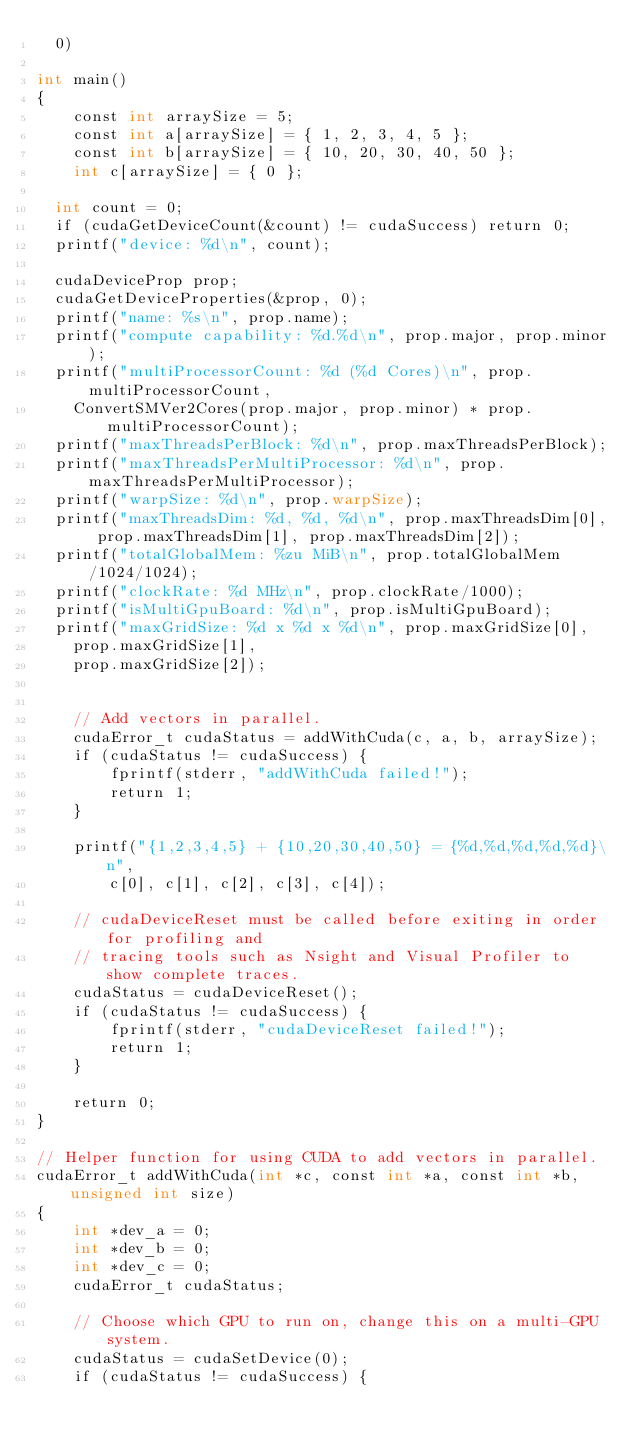Convert code to text. <code><loc_0><loc_0><loc_500><loc_500><_Cuda_>	0)

int main()
{
    const int arraySize = 5;
    const int a[arraySize] = { 1, 2, 3, 4, 5 };
    const int b[arraySize] = { 10, 20, 30, 40, 50 };
    int c[arraySize] = { 0 };

	int count = 0;
	if (cudaGetDeviceCount(&count) != cudaSuccess) return 0;
	printf("device: %d\n", count);

	cudaDeviceProp prop;
	cudaGetDeviceProperties(&prop, 0);
	printf("name: %s\n", prop.name);
	printf("compute capability: %d.%d\n", prop.major, prop.minor);
	printf("multiProcessorCount: %d (%d Cores)\n", prop.multiProcessorCount, 
		ConvertSMVer2Cores(prop.major, prop.minor) * prop.multiProcessorCount);
	printf("maxThreadsPerBlock: %d\n", prop.maxThreadsPerBlock);
	printf("maxThreadsPerMultiProcessor: %d\n", prop.maxThreadsPerMultiProcessor);
	printf("warpSize: %d\n", prop.warpSize);
	printf("maxThreadsDim: %d, %d, %d\n", prop.maxThreadsDim[0], prop.maxThreadsDim[1], prop.maxThreadsDim[2]);
	printf("totalGlobalMem: %zu MiB\n", prop.totalGlobalMem/1024/1024);
	printf("clockRate: %d MHz\n", prop.clockRate/1000);
	printf("isMultiGpuBoard: %d\n", prop.isMultiGpuBoard);
	printf("maxGridSize: %d x %d x %d\n", prop.maxGridSize[0], 
		prop.maxGridSize[1], 
		prop.maxGridSize[2]);


    // Add vectors in parallel.
    cudaError_t cudaStatus = addWithCuda(c, a, b, arraySize);
    if (cudaStatus != cudaSuccess) {
        fprintf(stderr, "addWithCuda failed!");
        return 1;
    }

    printf("{1,2,3,4,5} + {10,20,30,40,50} = {%d,%d,%d,%d,%d}\n",
        c[0], c[1], c[2], c[3], c[4]);

    // cudaDeviceReset must be called before exiting in order for profiling and
    // tracing tools such as Nsight and Visual Profiler to show complete traces.
    cudaStatus = cudaDeviceReset();
    if (cudaStatus != cudaSuccess) {
        fprintf(stderr, "cudaDeviceReset failed!");
        return 1;
    }

    return 0;
}

// Helper function for using CUDA to add vectors in parallel.
cudaError_t addWithCuda(int *c, const int *a, const int *b, unsigned int size)
{
    int *dev_a = 0;
    int *dev_b = 0;
    int *dev_c = 0;
    cudaError_t cudaStatus;

    // Choose which GPU to run on, change this on a multi-GPU system.
    cudaStatus = cudaSetDevice(0);
    if (cudaStatus != cudaSuccess) {</code> 